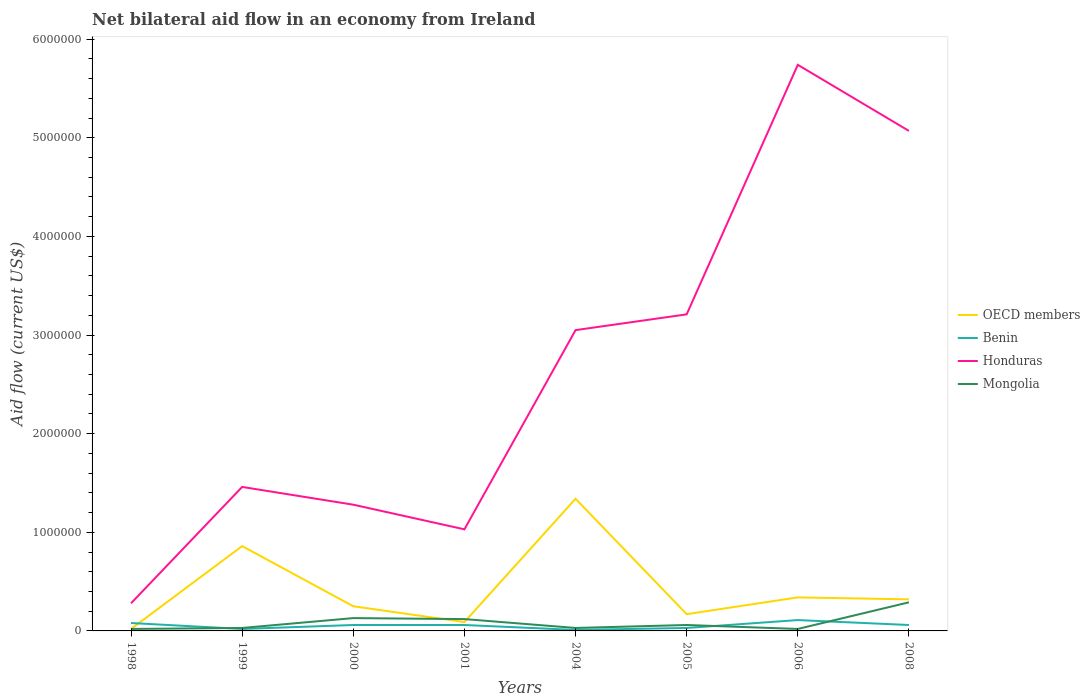Across all years, what is the maximum net bilateral aid flow in Honduras?
Give a very brief answer. 2.80e+05. What is the difference between the highest and the second highest net bilateral aid flow in OECD members?
Your answer should be compact. 1.32e+06. Is the net bilateral aid flow in Mongolia strictly greater than the net bilateral aid flow in Benin over the years?
Give a very brief answer. No. How many lines are there?
Ensure brevity in your answer.  4. What is the difference between two consecutive major ticks on the Y-axis?
Give a very brief answer. 1.00e+06. Are the values on the major ticks of Y-axis written in scientific E-notation?
Provide a succinct answer. No. Does the graph contain any zero values?
Provide a succinct answer. No. Does the graph contain grids?
Provide a succinct answer. No. Where does the legend appear in the graph?
Your answer should be compact. Center right. How are the legend labels stacked?
Ensure brevity in your answer.  Vertical. What is the title of the graph?
Your answer should be very brief. Net bilateral aid flow in an economy from Ireland. What is the label or title of the Y-axis?
Provide a succinct answer. Aid flow (current US$). What is the Aid flow (current US$) in Mongolia in 1998?
Your response must be concise. 2.00e+04. What is the Aid flow (current US$) of OECD members in 1999?
Give a very brief answer. 8.60e+05. What is the Aid flow (current US$) of Benin in 1999?
Your answer should be very brief. 2.00e+04. What is the Aid flow (current US$) of Honduras in 1999?
Make the answer very short. 1.46e+06. What is the Aid flow (current US$) of Mongolia in 1999?
Give a very brief answer. 3.00e+04. What is the Aid flow (current US$) of Benin in 2000?
Make the answer very short. 6.00e+04. What is the Aid flow (current US$) in Honduras in 2000?
Offer a very short reply. 1.28e+06. What is the Aid flow (current US$) in Honduras in 2001?
Provide a succinct answer. 1.03e+06. What is the Aid flow (current US$) of Mongolia in 2001?
Give a very brief answer. 1.20e+05. What is the Aid flow (current US$) in OECD members in 2004?
Provide a short and direct response. 1.34e+06. What is the Aid flow (current US$) in Benin in 2004?
Your response must be concise. 10000. What is the Aid flow (current US$) in Honduras in 2004?
Ensure brevity in your answer.  3.05e+06. What is the Aid flow (current US$) in OECD members in 2005?
Your answer should be compact. 1.70e+05. What is the Aid flow (current US$) of Benin in 2005?
Offer a very short reply. 3.00e+04. What is the Aid flow (current US$) of Honduras in 2005?
Offer a very short reply. 3.21e+06. What is the Aid flow (current US$) of Benin in 2006?
Offer a very short reply. 1.10e+05. What is the Aid flow (current US$) of Honduras in 2006?
Your response must be concise. 5.74e+06. What is the Aid flow (current US$) of Mongolia in 2006?
Offer a very short reply. 2.00e+04. What is the Aid flow (current US$) of OECD members in 2008?
Make the answer very short. 3.20e+05. What is the Aid flow (current US$) of Honduras in 2008?
Your answer should be very brief. 5.07e+06. What is the Aid flow (current US$) in Mongolia in 2008?
Give a very brief answer. 2.90e+05. Across all years, what is the maximum Aid flow (current US$) of OECD members?
Provide a short and direct response. 1.34e+06. Across all years, what is the maximum Aid flow (current US$) of Honduras?
Offer a very short reply. 5.74e+06. Across all years, what is the maximum Aid flow (current US$) of Mongolia?
Keep it short and to the point. 2.90e+05. Across all years, what is the minimum Aid flow (current US$) of Benin?
Your answer should be compact. 10000. Across all years, what is the minimum Aid flow (current US$) in Honduras?
Ensure brevity in your answer.  2.80e+05. Across all years, what is the minimum Aid flow (current US$) of Mongolia?
Offer a terse response. 2.00e+04. What is the total Aid flow (current US$) of OECD members in the graph?
Ensure brevity in your answer.  3.39e+06. What is the total Aid flow (current US$) of Honduras in the graph?
Make the answer very short. 2.11e+07. What is the difference between the Aid flow (current US$) in OECD members in 1998 and that in 1999?
Keep it short and to the point. -8.40e+05. What is the difference between the Aid flow (current US$) of Benin in 1998 and that in 1999?
Your answer should be compact. 6.00e+04. What is the difference between the Aid flow (current US$) in Honduras in 1998 and that in 1999?
Offer a very short reply. -1.18e+06. What is the difference between the Aid flow (current US$) in Mongolia in 1998 and that in 2000?
Give a very brief answer. -1.10e+05. What is the difference between the Aid flow (current US$) of OECD members in 1998 and that in 2001?
Keep it short and to the point. -7.00e+04. What is the difference between the Aid flow (current US$) of Honduras in 1998 and that in 2001?
Offer a terse response. -7.50e+05. What is the difference between the Aid flow (current US$) of Mongolia in 1998 and that in 2001?
Your answer should be compact. -1.00e+05. What is the difference between the Aid flow (current US$) of OECD members in 1998 and that in 2004?
Your answer should be compact. -1.32e+06. What is the difference between the Aid flow (current US$) of Benin in 1998 and that in 2004?
Your answer should be compact. 7.00e+04. What is the difference between the Aid flow (current US$) in Honduras in 1998 and that in 2004?
Your answer should be very brief. -2.77e+06. What is the difference between the Aid flow (current US$) of Mongolia in 1998 and that in 2004?
Offer a terse response. -10000. What is the difference between the Aid flow (current US$) of OECD members in 1998 and that in 2005?
Your response must be concise. -1.50e+05. What is the difference between the Aid flow (current US$) in Honduras in 1998 and that in 2005?
Provide a short and direct response. -2.93e+06. What is the difference between the Aid flow (current US$) in Mongolia in 1998 and that in 2005?
Ensure brevity in your answer.  -4.00e+04. What is the difference between the Aid flow (current US$) of OECD members in 1998 and that in 2006?
Offer a terse response. -3.20e+05. What is the difference between the Aid flow (current US$) of Benin in 1998 and that in 2006?
Your answer should be compact. -3.00e+04. What is the difference between the Aid flow (current US$) in Honduras in 1998 and that in 2006?
Your answer should be compact. -5.46e+06. What is the difference between the Aid flow (current US$) of Mongolia in 1998 and that in 2006?
Make the answer very short. 0. What is the difference between the Aid flow (current US$) of Benin in 1998 and that in 2008?
Provide a short and direct response. 2.00e+04. What is the difference between the Aid flow (current US$) of Honduras in 1998 and that in 2008?
Your answer should be very brief. -4.79e+06. What is the difference between the Aid flow (current US$) in Mongolia in 1998 and that in 2008?
Give a very brief answer. -2.70e+05. What is the difference between the Aid flow (current US$) in OECD members in 1999 and that in 2000?
Offer a very short reply. 6.10e+05. What is the difference between the Aid flow (current US$) of Honduras in 1999 and that in 2000?
Provide a short and direct response. 1.80e+05. What is the difference between the Aid flow (current US$) of Mongolia in 1999 and that in 2000?
Offer a terse response. -1.00e+05. What is the difference between the Aid flow (current US$) of OECD members in 1999 and that in 2001?
Make the answer very short. 7.70e+05. What is the difference between the Aid flow (current US$) in Benin in 1999 and that in 2001?
Your answer should be very brief. -4.00e+04. What is the difference between the Aid flow (current US$) in Mongolia in 1999 and that in 2001?
Provide a short and direct response. -9.00e+04. What is the difference between the Aid flow (current US$) of OECD members in 1999 and that in 2004?
Offer a terse response. -4.80e+05. What is the difference between the Aid flow (current US$) in Honduras in 1999 and that in 2004?
Your response must be concise. -1.59e+06. What is the difference between the Aid flow (current US$) of Mongolia in 1999 and that in 2004?
Offer a terse response. 0. What is the difference between the Aid flow (current US$) of OECD members in 1999 and that in 2005?
Provide a succinct answer. 6.90e+05. What is the difference between the Aid flow (current US$) in Benin in 1999 and that in 2005?
Offer a terse response. -10000. What is the difference between the Aid flow (current US$) of Honduras in 1999 and that in 2005?
Ensure brevity in your answer.  -1.75e+06. What is the difference between the Aid flow (current US$) in OECD members in 1999 and that in 2006?
Provide a succinct answer. 5.20e+05. What is the difference between the Aid flow (current US$) of Honduras in 1999 and that in 2006?
Provide a succinct answer. -4.28e+06. What is the difference between the Aid flow (current US$) in Mongolia in 1999 and that in 2006?
Offer a very short reply. 10000. What is the difference between the Aid flow (current US$) of OECD members in 1999 and that in 2008?
Offer a very short reply. 5.40e+05. What is the difference between the Aid flow (current US$) in Honduras in 1999 and that in 2008?
Offer a terse response. -3.61e+06. What is the difference between the Aid flow (current US$) of Mongolia in 1999 and that in 2008?
Ensure brevity in your answer.  -2.60e+05. What is the difference between the Aid flow (current US$) in OECD members in 2000 and that in 2001?
Give a very brief answer. 1.60e+05. What is the difference between the Aid flow (current US$) of OECD members in 2000 and that in 2004?
Give a very brief answer. -1.09e+06. What is the difference between the Aid flow (current US$) of Benin in 2000 and that in 2004?
Offer a very short reply. 5.00e+04. What is the difference between the Aid flow (current US$) of Honduras in 2000 and that in 2004?
Your answer should be very brief. -1.77e+06. What is the difference between the Aid flow (current US$) of Mongolia in 2000 and that in 2004?
Your response must be concise. 1.00e+05. What is the difference between the Aid flow (current US$) of OECD members in 2000 and that in 2005?
Your answer should be very brief. 8.00e+04. What is the difference between the Aid flow (current US$) of Benin in 2000 and that in 2005?
Offer a terse response. 3.00e+04. What is the difference between the Aid flow (current US$) of Honduras in 2000 and that in 2005?
Your response must be concise. -1.93e+06. What is the difference between the Aid flow (current US$) in OECD members in 2000 and that in 2006?
Your response must be concise. -9.00e+04. What is the difference between the Aid flow (current US$) of Honduras in 2000 and that in 2006?
Offer a terse response. -4.46e+06. What is the difference between the Aid flow (current US$) of Mongolia in 2000 and that in 2006?
Ensure brevity in your answer.  1.10e+05. What is the difference between the Aid flow (current US$) of Honduras in 2000 and that in 2008?
Give a very brief answer. -3.79e+06. What is the difference between the Aid flow (current US$) of OECD members in 2001 and that in 2004?
Give a very brief answer. -1.25e+06. What is the difference between the Aid flow (current US$) in Benin in 2001 and that in 2004?
Provide a short and direct response. 5.00e+04. What is the difference between the Aid flow (current US$) of Honduras in 2001 and that in 2004?
Offer a very short reply. -2.02e+06. What is the difference between the Aid flow (current US$) of Benin in 2001 and that in 2005?
Offer a very short reply. 3.00e+04. What is the difference between the Aid flow (current US$) in Honduras in 2001 and that in 2005?
Offer a very short reply. -2.18e+06. What is the difference between the Aid flow (current US$) in OECD members in 2001 and that in 2006?
Your answer should be very brief. -2.50e+05. What is the difference between the Aid flow (current US$) in Benin in 2001 and that in 2006?
Provide a short and direct response. -5.00e+04. What is the difference between the Aid flow (current US$) of Honduras in 2001 and that in 2006?
Ensure brevity in your answer.  -4.71e+06. What is the difference between the Aid flow (current US$) in OECD members in 2001 and that in 2008?
Make the answer very short. -2.30e+05. What is the difference between the Aid flow (current US$) of Honduras in 2001 and that in 2008?
Offer a terse response. -4.04e+06. What is the difference between the Aid flow (current US$) of OECD members in 2004 and that in 2005?
Keep it short and to the point. 1.17e+06. What is the difference between the Aid flow (current US$) of Benin in 2004 and that in 2005?
Ensure brevity in your answer.  -2.00e+04. What is the difference between the Aid flow (current US$) of Mongolia in 2004 and that in 2005?
Provide a succinct answer. -3.00e+04. What is the difference between the Aid flow (current US$) of OECD members in 2004 and that in 2006?
Make the answer very short. 1.00e+06. What is the difference between the Aid flow (current US$) in Benin in 2004 and that in 2006?
Ensure brevity in your answer.  -1.00e+05. What is the difference between the Aid flow (current US$) in Honduras in 2004 and that in 2006?
Your response must be concise. -2.69e+06. What is the difference between the Aid flow (current US$) in OECD members in 2004 and that in 2008?
Your answer should be very brief. 1.02e+06. What is the difference between the Aid flow (current US$) in Benin in 2004 and that in 2008?
Offer a very short reply. -5.00e+04. What is the difference between the Aid flow (current US$) in Honduras in 2004 and that in 2008?
Your response must be concise. -2.02e+06. What is the difference between the Aid flow (current US$) of Benin in 2005 and that in 2006?
Keep it short and to the point. -8.00e+04. What is the difference between the Aid flow (current US$) in Honduras in 2005 and that in 2006?
Provide a succinct answer. -2.53e+06. What is the difference between the Aid flow (current US$) of Mongolia in 2005 and that in 2006?
Provide a short and direct response. 4.00e+04. What is the difference between the Aid flow (current US$) of Honduras in 2005 and that in 2008?
Your answer should be compact. -1.86e+06. What is the difference between the Aid flow (current US$) in OECD members in 2006 and that in 2008?
Give a very brief answer. 2.00e+04. What is the difference between the Aid flow (current US$) of Benin in 2006 and that in 2008?
Your answer should be compact. 5.00e+04. What is the difference between the Aid flow (current US$) in Honduras in 2006 and that in 2008?
Offer a terse response. 6.70e+05. What is the difference between the Aid flow (current US$) in Mongolia in 2006 and that in 2008?
Keep it short and to the point. -2.70e+05. What is the difference between the Aid flow (current US$) of OECD members in 1998 and the Aid flow (current US$) of Benin in 1999?
Ensure brevity in your answer.  0. What is the difference between the Aid flow (current US$) of OECD members in 1998 and the Aid flow (current US$) of Honduras in 1999?
Your response must be concise. -1.44e+06. What is the difference between the Aid flow (current US$) of Benin in 1998 and the Aid flow (current US$) of Honduras in 1999?
Offer a very short reply. -1.38e+06. What is the difference between the Aid flow (current US$) in OECD members in 1998 and the Aid flow (current US$) in Honduras in 2000?
Provide a short and direct response. -1.26e+06. What is the difference between the Aid flow (current US$) of OECD members in 1998 and the Aid flow (current US$) of Mongolia in 2000?
Offer a very short reply. -1.10e+05. What is the difference between the Aid flow (current US$) in Benin in 1998 and the Aid flow (current US$) in Honduras in 2000?
Keep it short and to the point. -1.20e+06. What is the difference between the Aid flow (current US$) in Benin in 1998 and the Aid flow (current US$) in Mongolia in 2000?
Your answer should be very brief. -5.00e+04. What is the difference between the Aid flow (current US$) in OECD members in 1998 and the Aid flow (current US$) in Honduras in 2001?
Make the answer very short. -1.01e+06. What is the difference between the Aid flow (current US$) in Benin in 1998 and the Aid flow (current US$) in Honduras in 2001?
Your answer should be compact. -9.50e+05. What is the difference between the Aid flow (current US$) in Benin in 1998 and the Aid flow (current US$) in Mongolia in 2001?
Your answer should be compact. -4.00e+04. What is the difference between the Aid flow (current US$) of Honduras in 1998 and the Aid flow (current US$) of Mongolia in 2001?
Your answer should be very brief. 1.60e+05. What is the difference between the Aid flow (current US$) in OECD members in 1998 and the Aid flow (current US$) in Benin in 2004?
Offer a very short reply. 10000. What is the difference between the Aid flow (current US$) of OECD members in 1998 and the Aid flow (current US$) of Honduras in 2004?
Ensure brevity in your answer.  -3.03e+06. What is the difference between the Aid flow (current US$) of Benin in 1998 and the Aid flow (current US$) of Honduras in 2004?
Ensure brevity in your answer.  -2.97e+06. What is the difference between the Aid flow (current US$) in Benin in 1998 and the Aid flow (current US$) in Mongolia in 2004?
Your answer should be compact. 5.00e+04. What is the difference between the Aid flow (current US$) in Honduras in 1998 and the Aid flow (current US$) in Mongolia in 2004?
Your answer should be compact. 2.50e+05. What is the difference between the Aid flow (current US$) of OECD members in 1998 and the Aid flow (current US$) of Benin in 2005?
Offer a very short reply. -10000. What is the difference between the Aid flow (current US$) of OECD members in 1998 and the Aid flow (current US$) of Honduras in 2005?
Your response must be concise. -3.19e+06. What is the difference between the Aid flow (current US$) in Benin in 1998 and the Aid flow (current US$) in Honduras in 2005?
Your answer should be very brief. -3.13e+06. What is the difference between the Aid flow (current US$) of Benin in 1998 and the Aid flow (current US$) of Mongolia in 2005?
Give a very brief answer. 2.00e+04. What is the difference between the Aid flow (current US$) of OECD members in 1998 and the Aid flow (current US$) of Honduras in 2006?
Your response must be concise. -5.72e+06. What is the difference between the Aid flow (current US$) in Benin in 1998 and the Aid flow (current US$) in Honduras in 2006?
Offer a terse response. -5.66e+06. What is the difference between the Aid flow (current US$) of Benin in 1998 and the Aid flow (current US$) of Mongolia in 2006?
Make the answer very short. 6.00e+04. What is the difference between the Aid flow (current US$) of OECD members in 1998 and the Aid flow (current US$) of Benin in 2008?
Offer a terse response. -4.00e+04. What is the difference between the Aid flow (current US$) in OECD members in 1998 and the Aid flow (current US$) in Honduras in 2008?
Provide a succinct answer. -5.05e+06. What is the difference between the Aid flow (current US$) of Benin in 1998 and the Aid flow (current US$) of Honduras in 2008?
Your response must be concise. -4.99e+06. What is the difference between the Aid flow (current US$) of Benin in 1998 and the Aid flow (current US$) of Mongolia in 2008?
Your response must be concise. -2.10e+05. What is the difference between the Aid flow (current US$) in OECD members in 1999 and the Aid flow (current US$) in Benin in 2000?
Offer a terse response. 8.00e+05. What is the difference between the Aid flow (current US$) of OECD members in 1999 and the Aid flow (current US$) of Honduras in 2000?
Make the answer very short. -4.20e+05. What is the difference between the Aid flow (current US$) of OECD members in 1999 and the Aid flow (current US$) of Mongolia in 2000?
Provide a short and direct response. 7.30e+05. What is the difference between the Aid flow (current US$) of Benin in 1999 and the Aid flow (current US$) of Honduras in 2000?
Provide a short and direct response. -1.26e+06. What is the difference between the Aid flow (current US$) of Benin in 1999 and the Aid flow (current US$) of Mongolia in 2000?
Offer a very short reply. -1.10e+05. What is the difference between the Aid flow (current US$) in Honduras in 1999 and the Aid flow (current US$) in Mongolia in 2000?
Keep it short and to the point. 1.33e+06. What is the difference between the Aid flow (current US$) in OECD members in 1999 and the Aid flow (current US$) in Benin in 2001?
Offer a very short reply. 8.00e+05. What is the difference between the Aid flow (current US$) in OECD members in 1999 and the Aid flow (current US$) in Mongolia in 2001?
Your answer should be very brief. 7.40e+05. What is the difference between the Aid flow (current US$) of Benin in 1999 and the Aid flow (current US$) of Honduras in 2001?
Your answer should be very brief. -1.01e+06. What is the difference between the Aid flow (current US$) in Honduras in 1999 and the Aid flow (current US$) in Mongolia in 2001?
Ensure brevity in your answer.  1.34e+06. What is the difference between the Aid flow (current US$) in OECD members in 1999 and the Aid flow (current US$) in Benin in 2004?
Your response must be concise. 8.50e+05. What is the difference between the Aid flow (current US$) in OECD members in 1999 and the Aid flow (current US$) in Honduras in 2004?
Keep it short and to the point. -2.19e+06. What is the difference between the Aid flow (current US$) in OECD members in 1999 and the Aid flow (current US$) in Mongolia in 2004?
Provide a succinct answer. 8.30e+05. What is the difference between the Aid flow (current US$) of Benin in 1999 and the Aid flow (current US$) of Honduras in 2004?
Your response must be concise. -3.03e+06. What is the difference between the Aid flow (current US$) in Benin in 1999 and the Aid flow (current US$) in Mongolia in 2004?
Give a very brief answer. -10000. What is the difference between the Aid flow (current US$) in Honduras in 1999 and the Aid flow (current US$) in Mongolia in 2004?
Keep it short and to the point. 1.43e+06. What is the difference between the Aid flow (current US$) of OECD members in 1999 and the Aid flow (current US$) of Benin in 2005?
Keep it short and to the point. 8.30e+05. What is the difference between the Aid flow (current US$) of OECD members in 1999 and the Aid flow (current US$) of Honduras in 2005?
Give a very brief answer. -2.35e+06. What is the difference between the Aid flow (current US$) in OECD members in 1999 and the Aid flow (current US$) in Mongolia in 2005?
Give a very brief answer. 8.00e+05. What is the difference between the Aid flow (current US$) in Benin in 1999 and the Aid flow (current US$) in Honduras in 2005?
Give a very brief answer. -3.19e+06. What is the difference between the Aid flow (current US$) of Honduras in 1999 and the Aid flow (current US$) of Mongolia in 2005?
Your response must be concise. 1.40e+06. What is the difference between the Aid flow (current US$) in OECD members in 1999 and the Aid flow (current US$) in Benin in 2006?
Make the answer very short. 7.50e+05. What is the difference between the Aid flow (current US$) of OECD members in 1999 and the Aid flow (current US$) of Honduras in 2006?
Give a very brief answer. -4.88e+06. What is the difference between the Aid flow (current US$) in OECD members in 1999 and the Aid flow (current US$) in Mongolia in 2006?
Your response must be concise. 8.40e+05. What is the difference between the Aid flow (current US$) of Benin in 1999 and the Aid flow (current US$) of Honduras in 2006?
Your response must be concise. -5.72e+06. What is the difference between the Aid flow (current US$) in Benin in 1999 and the Aid flow (current US$) in Mongolia in 2006?
Offer a very short reply. 0. What is the difference between the Aid flow (current US$) in Honduras in 1999 and the Aid flow (current US$) in Mongolia in 2006?
Offer a very short reply. 1.44e+06. What is the difference between the Aid flow (current US$) in OECD members in 1999 and the Aid flow (current US$) in Benin in 2008?
Provide a short and direct response. 8.00e+05. What is the difference between the Aid flow (current US$) in OECD members in 1999 and the Aid flow (current US$) in Honduras in 2008?
Offer a very short reply. -4.21e+06. What is the difference between the Aid flow (current US$) in OECD members in 1999 and the Aid flow (current US$) in Mongolia in 2008?
Your response must be concise. 5.70e+05. What is the difference between the Aid flow (current US$) of Benin in 1999 and the Aid flow (current US$) of Honduras in 2008?
Provide a short and direct response. -5.05e+06. What is the difference between the Aid flow (current US$) in Benin in 1999 and the Aid flow (current US$) in Mongolia in 2008?
Your answer should be compact. -2.70e+05. What is the difference between the Aid flow (current US$) in Honduras in 1999 and the Aid flow (current US$) in Mongolia in 2008?
Provide a short and direct response. 1.17e+06. What is the difference between the Aid flow (current US$) in OECD members in 2000 and the Aid flow (current US$) in Benin in 2001?
Provide a short and direct response. 1.90e+05. What is the difference between the Aid flow (current US$) in OECD members in 2000 and the Aid flow (current US$) in Honduras in 2001?
Offer a very short reply. -7.80e+05. What is the difference between the Aid flow (current US$) in Benin in 2000 and the Aid flow (current US$) in Honduras in 2001?
Offer a terse response. -9.70e+05. What is the difference between the Aid flow (current US$) in Honduras in 2000 and the Aid flow (current US$) in Mongolia in 2001?
Provide a short and direct response. 1.16e+06. What is the difference between the Aid flow (current US$) of OECD members in 2000 and the Aid flow (current US$) of Benin in 2004?
Ensure brevity in your answer.  2.40e+05. What is the difference between the Aid flow (current US$) in OECD members in 2000 and the Aid flow (current US$) in Honduras in 2004?
Ensure brevity in your answer.  -2.80e+06. What is the difference between the Aid flow (current US$) of OECD members in 2000 and the Aid flow (current US$) of Mongolia in 2004?
Give a very brief answer. 2.20e+05. What is the difference between the Aid flow (current US$) in Benin in 2000 and the Aid flow (current US$) in Honduras in 2004?
Offer a very short reply. -2.99e+06. What is the difference between the Aid flow (current US$) of Benin in 2000 and the Aid flow (current US$) of Mongolia in 2004?
Make the answer very short. 3.00e+04. What is the difference between the Aid flow (current US$) in Honduras in 2000 and the Aid flow (current US$) in Mongolia in 2004?
Offer a terse response. 1.25e+06. What is the difference between the Aid flow (current US$) in OECD members in 2000 and the Aid flow (current US$) in Benin in 2005?
Your response must be concise. 2.20e+05. What is the difference between the Aid flow (current US$) in OECD members in 2000 and the Aid flow (current US$) in Honduras in 2005?
Provide a succinct answer. -2.96e+06. What is the difference between the Aid flow (current US$) of Benin in 2000 and the Aid flow (current US$) of Honduras in 2005?
Offer a very short reply. -3.15e+06. What is the difference between the Aid flow (current US$) of Benin in 2000 and the Aid flow (current US$) of Mongolia in 2005?
Provide a succinct answer. 0. What is the difference between the Aid flow (current US$) in Honduras in 2000 and the Aid flow (current US$) in Mongolia in 2005?
Keep it short and to the point. 1.22e+06. What is the difference between the Aid flow (current US$) in OECD members in 2000 and the Aid flow (current US$) in Benin in 2006?
Your answer should be compact. 1.40e+05. What is the difference between the Aid flow (current US$) in OECD members in 2000 and the Aid flow (current US$) in Honduras in 2006?
Ensure brevity in your answer.  -5.49e+06. What is the difference between the Aid flow (current US$) of Benin in 2000 and the Aid flow (current US$) of Honduras in 2006?
Ensure brevity in your answer.  -5.68e+06. What is the difference between the Aid flow (current US$) in Benin in 2000 and the Aid flow (current US$) in Mongolia in 2006?
Keep it short and to the point. 4.00e+04. What is the difference between the Aid flow (current US$) in Honduras in 2000 and the Aid flow (current US$) in Mongolia in 2006?
Provide a succinct answer. 1.26e+06. What is the difference between the Aid flow (current US$) in OECD members in 2000 and the Aid flow (current US$) in Benin in 2008?
Ensure brevity in your answer.  1.90e+05. What is the difference between the Aid flow (current US$) in OECD members in 2000 and the Aid flow (current US$) in Honduras in 2008?
Provide a short and direct response. -4.82e+06. What is the difference between the Aid flow (current US$) in OECD members in 2000 and the Aid flow (current US$) in Mongolia in 2008?
Offer a terse response. -4.00e+04. What is the difference between the Aid flow (current US$) in Benin in 2000 and the Aid flow (current US$) in Honduras in 2008?
Provide a succinct answer. -5.01e+06. What is the difference between the Aid flow (current US$) of Benin in 2000 and the Aid flow (current US$) of Mongolia in 2008?
Ensure brevity in your answer.  -2.30e+05. What is the difference between the Aid flow (current US$) of Honduras in 2000 and the Aid flow (current US$) of Mongolia in 2008?
Keep it short and to the point. 9.90e+05. What is the difference between the Aid flow (current US$) of OECD members in 2001 and the Aid flow (current US$) of Benin in 2004?
Give a very brief answer. 8.00e+04. What is the difference between the Aid flow (current US$) of OECD members in 2001 and the Aid flow (current US$) of Honduras in 2004?
Provide a short and direct response. -2.96e+06. What is the difference between the Aid flow (current US$) in OECD members in 2001 and the Aid flow (current US$) in Mongolia in 2004?
Offer a terse response. 6.00e+04. What is the difference between the Aid flow (current US$) of Benin in 2001 and the Aid flow (current US$) of Honduras in 2004?
Ensure brevity in your answer.  -2.99e+06. What is the difference between the Aid flow (current US$) of Benin in 2001 and the Aid flow (current US$) of Mongolia in 2004?
Give a very brief answer. 3.00e+04. What is the difference between the Aid flow (current US$) of OECD members in 2001 and the Aid flow (current US$) of Honduras in 2005?
Offer a terse response. -3.12e+06. What is the difference between the Aid flow (current US$) of OECD members in 2001 and the Aid flow (current US$) of Mongolia in 2005?
Offer a terse response. 3.00e+04. What is the difference between the Aid flow (current US$) in Benin in 2001 and the Aid flow (current US$) in Honduras in 2005?
Provide a short and direct response. -3.15e+06. What is the difference between the Aid flow (current US$) of Honduras in 2001 and the Aid flow (current US$) of Mongolia in 2005?
Give a very brief answer. 9.70e+05. What is the difference between the Aid flow (current US$) in OECD members in 2001 and the Aid flow (current US$) in Honduras in 2006?
Ensure brevity in your answer.  -5.65e+06. What is the difference between the Aid flow (current US$) in Benin in 2001 and the Aid flow (current US$) in Honduras in 2006?
Your answer should be very brief. -5.68e+06. What is the difference between the Aid flow (current US$) of Honduras in 2001 and the Aid flow (current US$) of Mongolia in 2006?
Keep it short and to the point. 1.01e+06. What is the difference between the Aid flow (current US$) in OECD members in 2001 and the Aid flow (current US$) in Benin in 2008?
Keep it short and to the point. 3.00e+04. What is the difference between the Aid flow (current US$) in OECD members in 2001 and the Aid flow (current US$) in Honduras in 2008?
Offer a very short reply. -4.98e+06. What is the difference between the Aid flow (current US$) in Benin in 2001 and the Aid flow (current US$) in Honduras in 2008?
Your answer should be very brief. -5.01e+06. What is the difference between the Aid flow (current US$) of Benin in 2001 and the Aid flow (current US$) of Mongolia in 2008?
Your response must be concise. -2.30e+05. What is the difference between the Aid flow (current US$) of Honduras in 2001 and the Aid flow (current US$) of Mongolia in 2008?
Offer a terse response. 7.40e+05. What is the difference between the Aid flow (current US$) in OECD members in 2004 and the Aid flow (current US$) in Benin in 2005?
Your answer should be compact. 1.31e+06. What is the difference between the Aid flow (current US$) in OECD members in 2004 and the Aid flow (current US$) in Honduras in 2005?
Provide a succinct answer. -1.87e+06. What is the difference between the Aid flow (current US$) of OECD members in 2004 and the Aid flow (current US$) of Mongolia in 2005?
Your answer should be very brief. 1.28e+06. What is the difference between the Aid flow (current US$) in Benin in 2004 and the Aid flow (current US$) in Honduras in 2005?
Provide a short and direct response. -3.20e+06. What is the difference between the Aid flow (current US$) in Benin in 2004 and the Aid flow (current US$) in Mongolia in 2005?
Provide a succinct answer. -5.00e+04. What is the difference between the Aid flow (current US$) of Honduras in 2004 and the Aid flow (current US$) of Mongolia in 2005?
Ensure brevity in your answer.  2.99e+06. What is the difference between the Aid flow (current US$) in OECD members in 2004 and the Aid flow (current US$) in Benin in 2006?
Provide a succinct answer. 1.23e+06. What is the difference between the Aid flow (current US$) in OECD members in 2004 and the Aid flow (current US$) in Honduras in 2006?
Provide a short and direct response. -4.40e+06. What is the difference between the Aid flow (current US$) of OECD members in 2004 and the Aid flow (current US$) of Mongolia in 2006?
Give a very brief answer. 1.32e+06. What is the difference between the Aid flow (current US$) of Benin in 2004 and the Aid flow (current US$) of Honduras in 2006?
Your response must be concise. -5.73e+06. What is the difference between the Aid flow (current US$) in Honduras in 2004 and the Aid flow (current US$) in Mongolia in 2006?
Make the answer very short. 3.03e+06. What is the difference between the Aid flow (current US$) of OECD members in 2004 and the Aid flow (current US$) of Benin in 2008?
Provide a succinct answer. 1.28e+06. What is the difference between the Aid flow (current US$) in OECD members in 2004 and the Aid flow (current US$) in Honduras in 2008?
Keep it short and to the point. -3.73e+06. What is the difference between the Aid flow (current US$) of OECD members in 2004 and the Aid flow (current US$) of Mongolia in 2008?
Your answer should be compact. 1.05e+06. What is the difference between the Aid flow (current US$) in Benin in 2004 and the Aid flow (current US$) in Honduras in 2008?
Keep it short and to the point. -5.06e+06. What is the difference between the Aid flow (current US$) in Benin in 2004 and the Aid flow (current US$) in Mongolia in 2008?
Ensure brevity in your answer.  -2.80e+05. What is the difference between the Aid flow (current US$) of Honduras in 2004 and the Aid flow (current US$) of Mongolia in 2008?
Your response must be concise. 2.76e+06. What is the difference between the Aid flow (current US$) of OECD members in 2005 and the Aid flow (current US$) of Benin in 2006?
Your answer should be compact. 6.00e+04. What is the difference between the Aid flow (current US$) of OECD members in 2005 and the Aid flow (current US$) of Honduras in 2006?
Your answer should be compact. -5.57e+06. What is the difference between the Aid flow (current US$) in OECD members in 2005 and the Aid flow (current US$) in Mongolia in 2006?
Your answer should be compact. 1.50e+05. What is the difference between the Aid flow (current US$) in Benin in 2005 and the Aid flow (current US$) in Honduras in 2006?
Your answer should be very brief. -5.71e+06. What is the difference between the Aid flow (current US$) in Benin in 2005 and the Aid flow (current US$) in Mongolia in 2006?
Offer a very short reply. 10000. What is the difference between the Aid flow (current US$) of Honduras in 2005 and the Aid flow (current US$) of Mongolia in 2006?
Offer a terse response. 3.19e+06. What is the difference between the Aid flow (current US$) of OECD members in 2005 and the Aid flow (current US$) of Honduras in 2008?
Provide a short and direct response. -4.90e+06. What is the difference between the Aid flow (current US$) in Benin in 2005 and the Aid flow (current US$) in Honduras in 2008?
Offer a terse response. -5.04e+06. What is the difference between the Aid flow (current US$) in Honduras in 2005 and the Aid flow (current US$) in Mongolia in 2008?
Give a very brief answer. 2.92e+06. What is the difference between the Aid flow (current US$) of OECD members in 2006 and the Aid flow (current US$) of Honduras in 2008?
Provide a succinct answer. -4.73e+06. What is the difference between the Aid flow (current US$) of OECD members in 2006 and the Aid flow (current US$) of Mongolia in 2008?
Your answer should be compact. 5.00e+04. What is the difference between the Aid flow (current US$) in Benin in 2006 and the Aid flow (current US$) in Honduras in 2008?
Provide a short and direct response. -4.96e+06. What is the difference between the Aid flow (current US$) of Benin in 2006 and the Aid flow (current US$) of Mongolia in 2008?
Your answer should be very brief. -1.80e+05. What is the difference between the Aid flow (current US$) in Honduras in 2006 and the Aid flow (current US$) in Mongolia in 2008?
Give a very brief answer. 5.45e+06. What is the average Aid flow (current US$) in OECD members per year?
Provide a succinct answer. 4.24e+05. What is the average Aid flow (current US$) in Benin per year?
Your answer should be very brief. 5.38e+04. What is the average Aid flow (current US$) in Honduras per year?
Your response must be concise. 2.64e+06. What is the average Aid flow (current US$) in Mongolia per year?
Your answer should be very brief. 8.75e+04. In the year 1998, what is the difference between the Aid flow (current US$) of Honduras and Aid flow (current US$) of Mongolia?
Ensure brevity in your answer.  2.60e+05. In the year 1999, what is the difference between the Aid flow (current US$) of OECD members and Aid flow (current US$) of Benin?
Your answer should be very brief. 8.40e+05. In the year 1999, what is the difference between the Aid flow (current US$) of OECD members and Aid flow (current US$) of Honduras?
Your answer should be compact. -6.00e+05. In the year 1999, what is the difference between the Aid flow (current US$) of OECD members and Aid flow (current US$) of Mongolia?
Keep it short and to the point. 8.30e+05. In the year 1999, what is the difference between the Aid flow (current US$) of Benin and Aid flow (current US$) of Honduras?
Your response must be concise. -1.44e+06. In the year 1999, what is the difference between the Aid flow (current US$) in Honduras and Aid flow (current US$) in Mongolia?
Offer a very short reply. 1.43e+06. In the year 2000, what is the difference between the Aid flow (current US$) of OECD members and Aid flow (current US$) of Benin?
Your answer should be compact. 1.90e+05. In the year 2000, what is the difference between the Aid flow (current US$) in OECD members and Aid flow (current US$) in Honduras?
Your answer should be compact. -1.03e+06. In the year 2000, what is the difference between the Aid flow (current US$) in Benin and Aid flow (current US$) in Honduras?
Give a very brief answer. -1.22e+06. In the year 2000, what is the difference between the Aid flow (current US$) of Benin and Aid flow (current US$) of Mongolia?
Provide a short and direct response. -7.00e+04. In the year 2000, what is the difference between the Aid flow (current US$) in Honduras and Aid flow (current US$) in Mongolia?
Provide a short and direct response. 1.15e+06. In the year 2001, what is the difference between the Aid flow (current US$) in OECD members and Aid flow (current US$) in Benin?
Your response must be concise. 3.00e+04. In the year 2001, what is the difference between the Aid flow (current US$) in OECD members and Aid flow (current US$) in Honduras?
Ensure brevity in your answer.  -9.40e+05. In the year 2001, what is the difference between the Aid flow (current US$) of OECD members and Aid flow (current US$) of Mongolia?
Make the answer very short. -3.00e+04. In the year 2001, what is the difference between the Aid flow (current US$) of Benin and Aid flow (current US$) of Honduras?
Your answer should be very brief. -9.70e+05. In the year 2001, what is the difference between the Aid flow (current US$) of Honduras and Aid flow (current US$) of Mongolia?
Keep it short and to the point. 9.10e+05. In the year 2004, what is the difference between the Aid flow (current US$) in OECD members and Aid flow (current US$) in Benin?
Provide a succinct answer. 1.33e+06. In the year 2004, what is the difference between the Aid flow (current US$) in OECD members and Aid flow (current US$) in Honduras?
Offer a very short reply. -1.71e+06. In the year 2004, what is the difference between the Aid flow (current US$) in OECD members and Aid flow (current US$) in Mongolia?
Ensure brevity in your answer.  1.31e+06. In the year 2004, what is the difference between the Aid flow (current US$) of Benin and Aid flow (current US$) of Honduras?
Make the answer very short. -3.04e+06. In the year 2004, what is the difference between the Aid flow (current US$) in Benin and Aid flow (current US$) in Mongolia?
Your answer should be very brief. -2.00e+04. In the year 2004, what is the difference between the Aid flow (current US$) of Honduras and Aid flow (current US$) of Mongolia?
Provide a succinct answer. 3.02e+06. In the year 2005, what is the difference between the Aid flow (current US$) in OECD members and Aid flow (current US$) in Honduras?
Keep it short and to the point. -3.04e+06. In the year 2005, what is the difference between the Aid flow (current US$) in Benin and Aid flow (current US$) in Honduras?
Your response must be concise. -3.18e+06. In the year 2005, what is the difference between the Aid flow (current US$) in Honduras and Aid flow (current US$) in Mongolia?
Your response must be concise. 3.15e+06. In the year 2006, what is the difference between the Aid flow (current US$) of OECD members and Aid flow (current US$) of Benin?
Offer a terse response. 2.30e+05. In the year 2006, what is the difference between the Aid flow (current US$) in OECD members and Aid flow (current US$) in Honduras?
Provide a succinct answer. -5.40e+06. In the year 2006, what is the difference between the Aid flow (current US$) of OECD members and Aid flow (current US$) of Mongolia?
Your answer should be very brief. 3.20e+05. In the year 2006, what is the difference between the Aid flow (current US$) of Benin and Aid flow (current US$) of Honduras?
Ensure brevity in your answer.  -5.63e+06. In the year 2006, what is the difference between the Aid flow (current US$) of Benin and Aid flow (current US$) of Mongolia?
Make the answer very short. 9.00e+04. In the year 2006, what is the difference between the Aid flow (current US$) of Honduras and Aid flow (current US$) of Mongolia?
Offer a very short reply. 5.72e+06. In the year 2008, what is the difference between the Aid flow (current US$) in OECD members and Aid flow (current US$) in Honduras?
Provide a short and direct response. -4.75e+06. In the year 2008, what is the difference between the Aid flow (current US$) of Benin and Aid flow (current US$) of Honduras?
Offer a terse response. -5.01e+06. In the year 2008, what is the difference between the Aid flow (current US$) of Benin and Aid flow (current US$) of Mongolia?
Offer a very short reply. -2.30e+05. In the year 2008, what is the difference between the Aid flow (current US$) in Honduras and Aid flow (current US$) in Mongolia?
Keep it short and to the point. 4.78e+06. What is the ratio of the Aid flow (current US$) in OECD members in 1998 to that in 1999?
Offer a terse response. 0.02. What is the ratio of the Aid flow (current US$) in Benin in 1998 to that in 1999?
Make the answer very short. 4. What is the ratio of the Aid flow (current US$) of Honduras in 1998 to that in 1999?
Offer a very short reply. 0.19. What is the ratio of the Aid flow (current US$) in Mongolia in 1998 to that in 1999?
Offer a terse response. 0.67. What is the ratio of the Aid flow (current US$) in OECD members in 1998 to that in 2000?
Offer a very short reply. 0.08. What is the ratio of the Aid flow (current US$) in Benin in 1998 to that in 2000?
Your answer should be very brief. 1.33. What is the ratio of the Aid flow (current US$) in Honduras in 1998 to that in 2000?
Make the answer very short. 0.22. What is the ratio of the Aid flow (current US$) in Mongolia in 1998 to that in 2000?
Offer a terse response. 0.15. What is the ratio of the Aid flow (current US$) in OECD members in 1998 to that in 2001?
Provide a succinct answer. 0.22. What is the ratio of the Aid flow (current US$) of Benin in 1998 to that in 2001?
Your answer should be compact. 1.33. What is the ratio of the Aid flow (current US$) in Honduras in 1998 to that in 2001?
Ensure brevity in your answer.  0.27. What is the ratio of the Aid flow (current US$) in OECD members in 1998 to that in 2004?
Provide a short and direct response. 0.01. What is the ratio of the Aid flow (current US$) in Benin in 1998 to that in 2004?
Ensure brevity in your answer.  8. What is the ratio of the Aid flow (current US$) of Honduras in 1998 to that in 2004?
Your answer should be compact. 0.09. What is the ratio of the Aid flow (current US$) of OECD members in 1998 to that in 2005?
Your response must be concise. 0.12. What is the ratio of the Aid flow (current US$) of Benin in 1998 to that in 2005?
Offer a very short reply. 2.67. What is the ratio of the Aid flow (current US$) of Honduras in 1998 to that in 2005?
Your response must be concise. 0.09. What is the ratio of the Aid flow (current US$) in OECD members in 1998 to that in 2006?
Offer a very short reply. 0.06. What is the ratio of the Aid flow (current US$) in Benin in 1998 to that in 2006?
Keep it short and to the point. 0.73. What is the ratio of the Aid flow (current US$) of Honduras in 1998 to that in 2006?
Give a very brief answer. 0.05. What is the ratio of the Aid flow (current US$) in OECD members in 1998 to that in 2008?
Keep it short and to the point. 0.06. What is the ratio of the Aid flow (current US$) of Benin in 1998 to that in 2008?
Provide a succinct answer. 1.33. What is the ratio of the Aid flow (current US$) in Honduras in 1998 to that in 2008?
Ensure brevity in your answer.  0.06. What is the ratio of the Aid flow (current US$) of Mongolia in 1998 to that in 2008?
Keep it short and to the point. 0.07. What is the ratio of the Aid flow (current US$) of OECD members in 1999 to that in 2000?
Make the answer very short. 3.44. What is the ratio of the Aid flow (current US$) in Honduras in 1999 to that in 2000?
Your response must be concise. 1.14. What is the ratio of the Aid flow (current US$) of Mongolia in 1999 to that in 2000?
Give a very brief answer. 0.23. What is the ratio of the Aid flow (current US$) in OECD members in 1999 to that in 2001?
Make the answer very short. 9.56. What is the ratio of the Aid flow (current US$) in Honduras in 1999 to that in 2001?
Keep it short and to the point. 1.42. What is the ratio of the Aid flow (current US$) in OECD members in 1999 to that in 2004?
Offer a very short reply. 0.64. What is the ratio of the Aid flow (current US$) of Benin in 1999 to that in 2004?
Your answer should be very brief. 2. What is the ratio of the Aid flow (current US$) of Honduras in 1999 to that in 2004?
Ensure brevity in your answer.  0.48. What is the ratio of the Aid flow (current US$) in Mongolia in 1999 to that in 2004?
Make the answer very short. 1. What is the ratio of the Aid flow (current US$) of OECD members in 1999 to that in 2005?
Offer a terse response. 5.06. What is the ratio of the Aid flow (current US$) of Honduras in 1999 to that in 2005?
Your answer should be compact. 0.45. What is the ratio of the Aid flow (current US$) of OECD members in 1999 to that in 2006?
Your response must be concise. 2.53. What is the ratio of the Aid flow (current US$) in Benin in 1999 to that in 2006?
Make the answer very short. 0.18. What is the ratio of the Aid flow (current US$) in Honduras in 1999 to that in 2006?
Provide a succinct answer. 0.25. What is the ratio of the Aid flow (current US$) of Mongolia in 1999 to that in 2006?
Offer a very short reply. 1.5. What is the ratio of the Aid flow (current US$) of OECD members in 1999 to that in 2008?
Your answer should be compact. 2.69. What is the ratio of the Aid flow (current US$) of Benin in 1999 to that in 2008?
Offer a very short reply. 0.33. What is the ratio of the Aid flow (current US$) in Honduras in 1999 to that in 2008?
Offer a terse response. 0.29. What is the ratio of the Aid flow (current US$) of Mongolia in 1999 to that in 2008?
Provide a succinct answer. 0.1. What is the ratio of the Aid flow (current US$) of OECD members in 2000 to that in 2001?
Give a very brief answer. 2.78. What is the ratio of the Aid flow (current US$) in Benin in 2000 to that in 2001?
Offer a very short reply. 1. What is the ratio of the Aid flow (current US$) in Honduras in 2000 to that in 2001?
Your answer should be compact. 1.24. What is the ratio of the Aid flow (current US$) of Mongolia in 2000 to that in 2001?
Give a very brief answer. 1.08. What is the ratio of the Aid flow (current US$) of OECD members in 2000 to that in 2004?
Your answer should be very brief. 0.19. What is the ratio of the Aid flow (current US$) in Honduras in 2000 to that in 2004?
Offer a terse response. 0.42. What is the ratio of the Aid flow (current US$) in Mongolia in 2000 to that in 2004?
Give a very brief answer. 4.33. What is the ratio of the Aid flow (current US$) in OECD members in 2000 to that in 2005?
Provide a short and direct response. 1.47. What is the ratio of the Aid flow (current US$) in Benin in 2000 to that in 2005?
Make the answer very short. 2. What is the ratio of the Aid flow (current US$) of Honduras in 2000 to that in 2005?
Your answer should be very brief. 0.4. What is the ratio of the Aid flow (current US$) of Mongolia in 2000 to that in 2005?
Keep it short and to the point. 2.17. What is the ratio of the Aid flow (current US$) in OECD members in 2000 to that in 2006?
Offer a terse response. 0.74. What is the ratio of the Aid flow (current US$) in Benin in 2000 to that in 2006?
Offer a terse response. 0.55. What is the ratio of the Aid flow (current US$) of Honduras in 2000 to that in 2006?
Offer a very short reply. 0.22. What is the ratio of the Aid flow (current US$) in OECD members in 2000 to that in 2008?
Your answer should be very brief. 0.78. What is the ratio of the Aid flow (current US$) in Honduras in 2000 to that in 2008?
Your response must be concise. 0.25. What is the ratio of the Aid flow (current US$) in Mongolia in 2000 to that in 2008?
Offer a very short reply. 0.45. What is the ratio of the Aid flow (current US$) of OECD members in 2001 to that in 2004?
Keep it short and to the point. 0.07. What is the ratio of the Aid flow (current US$) in Benin in 2001 to that in 2004?
Your response must be concise. 6. What is the ratio of the Aid flow (current US$) of Honduras in 2001 to that in 2004?
Offer a very short reply. 0.34. What is the ratio of the Aid flow (current US$) of OECD members in 2001 to that in 2005?
Keep it short and to the point. 0.53. What is the ratio of the Aid flow (current US$) of Benin in 2001 to that in 2005?
Your answer should be compact. 2. What is the ratio of the Aid flow (current US$) in Honduras in 2001 to that in 2005?
Your answer should be compact. 0.32. What is the ratio of the Aid flow (current US$) of OECD members in 2001 to that in 2006?
Give a very brief answer. 0.26. What is the ratio of the Aid flow (current US$) in Benin in 2001 to that in 2006?
Keep it short and to the point. 0.55. What is the ratio of the Aid flow (current US$) in Honduras in 2001 to that in 2006?
Your response must be concise. 0.18. What is the ratio of the Aid flow (current US$) in OECD members in 2001 to that in 2008?
Your answer should be compact. 0.28. What is the ratio of the Aid flow (current US$) in Benin in 2001 to that in 2008?
Provide a succinct answer. 1. What is the ratio of the Aid flow (current US$) in Honduras in 2001 to that in 2008?
Your response must be concise. 0.2. What is the ratio of the Aid flow (current US$) of Mongolia in 2001 to that in 2008?
Your answer should be very brief. 0.41. What is the ratio of the Aid flow (current US$) of OECD members in 2004 to that in 2005?
Your response must be concise. 7.88. What is the ratio of the Aid flow (current US$) in Honduras in 2004 to that in 2005?
Your answer should be compact. 0.95. What is the ratio of the Aid flow (current US$) of OECD members in 2004 to that in 2006?
Give a very brief answer. 3.94. What is the ratio of the Aid flow (current US$) of Benin in 2004 to that in 2006?
Offer a very short reply. 0.09. What is the ratio of the Aid flow (current US$) of Honduras in 2004 to that in 2006?
Give a very brief answer. 0.53. What is the ratio of the Aid flow (current US$) in OECD members in 2004 to that in 2008?
Your response must be concise. 4.19. What is the ratio of the Aid flow (current US$) in Honduras in 2004 to that in 2008?
Your answer should be very brief. 0.6. What is the ratio of the Aid flow (current US$) in Mongolia in 2004 to that in 2008?
Make the answer very short. 0.1. What is the ratio of the Aid flow (current US$) in Benin in 2005 to that in 2006?
Your response must be concise. 0.27. What is the ratio of the Aid flow (current US$) of Honduras in 2005 to that in 2006?
Provide a succinct answer. 0.56. What is the ratio of the Aid flow (current US$) of Mongolia in 2005 to that in 2006?
Your answer should be compact. 3. What is the ratio of the Aid flow (current US$) in OECD members in 2005 to that in 2008?
Ensure brevity in your answer.  0.53. What is the ratio of the Aid flow (current US$) of Benin in 2005 to that in 2008?
Your response must be concise. 0.5. What is the ratio of the Aid flow (current US$) of Honduras in 2005 to that in 2008?
Offer a very short reply. 0.63. What is the ratio of the Aid flow (current US$) in Mongolia in 2005 to that in 2008?
Provide a short and direct response. 0.21. What is the ratio of the Aid flow (current US$) of OECD members in 2006 to that in 2008?
Offer a terse response. 1.06. What is the ratio of the Aid flow (current US$) of Benin in 2006 to that in 2008?
Provide a short and direct response. 1.83. What is the ratio of the Aid flow (current US$) of Honduras in 2006 to that in 2008?
Make the answer very short. 1.13. What is the ratio of the Aid flow (current US$) of Mongolia in 2006 to that in 2008?
Provide a succinct answer. 0.07. What is the difference between the highest and the second highest Aid flow (current US$) of OECD members?
Offer a terse response. 4.80e+05. What is the difference between the highest and the second highest Aid flow (current US$) of Honduras?
Make the answer very short. 6.70e+05. What is the difference between the highest and the second highest Aid flow (current US$) in Mongolia?
Give a very brief answer. 1.60e+05. What is the difference between the highest and the lowest Aid flow (current US$) of OECD members?
Ensure brevity in your answer.  1.32e+06. What is the difference between the highest and the lowest Aid flow (current US$) in Benin?
Your answer should be compact. 1.00e+05. What is the difference between the highest and the lowest Aid flow (current US$) of Honduras?
Your answer should be very brief. 5.46e+06. What is the difference between the highest and the lowest Aid flow (current US$) of Mongolia?
Keep it short and to the point. 2.70e+05. 